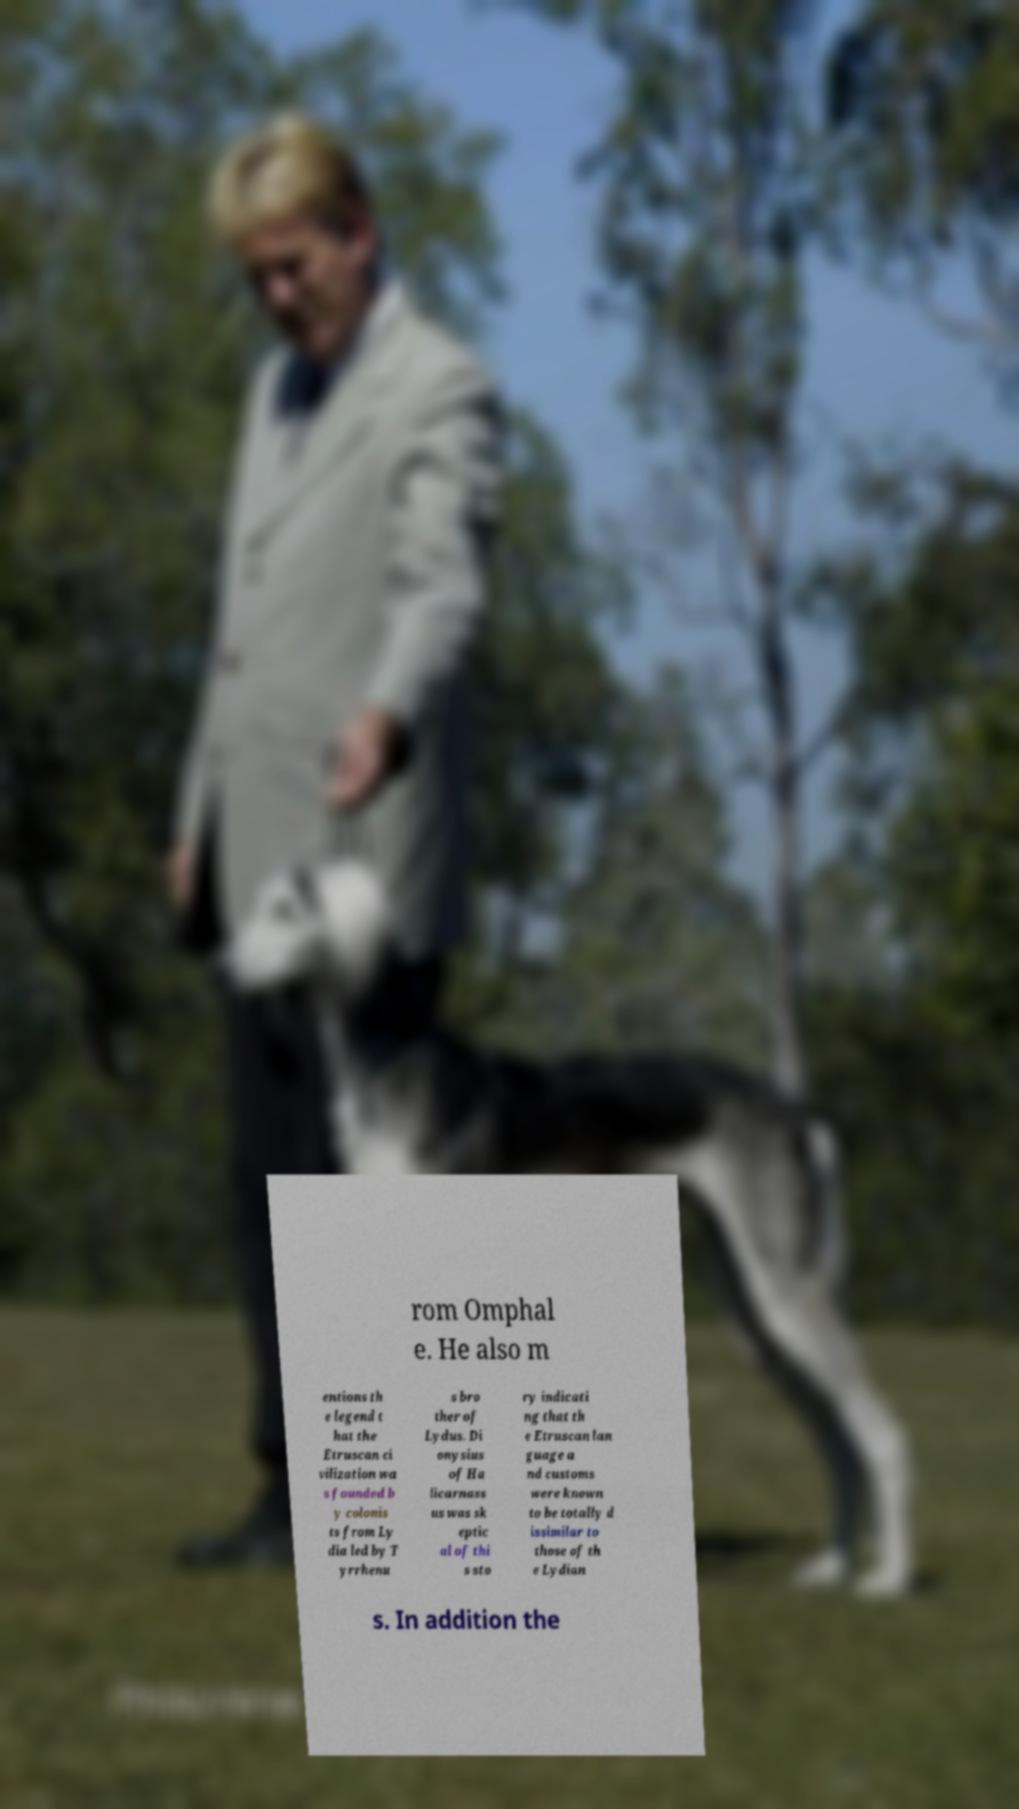Could you extract and type out the text from this image? rom Omphal e. He also m entions th e legend t hat the Etruscan ci vilization wa s founded b y colonis ts from Ly dia led by T yrrhenu s bro ther of Lydus. Di onysius of Ha licarnass us was sk eptic al of thi s sto ry indicati ng that th e Etruscan lan guage a nd customs were known to be totally d issimilar to those of th e Lydian s. In addition the 